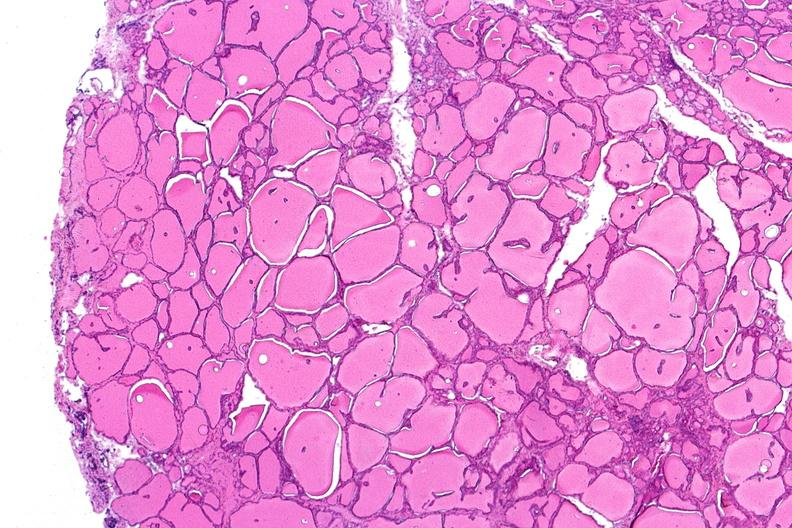what does this image show?
Answer the question using a single word or phrase. Thyroid 